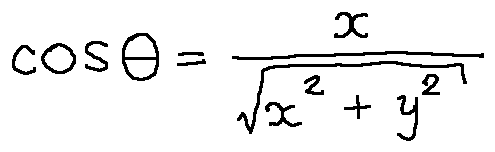Convert formula to latex. <formula><loc_0><loc_0><loc_500><loc_500>\cos \theta = \frac { x } { \sqrt { x ^ { 2 } + y ^ { 2 } } }</formula> 